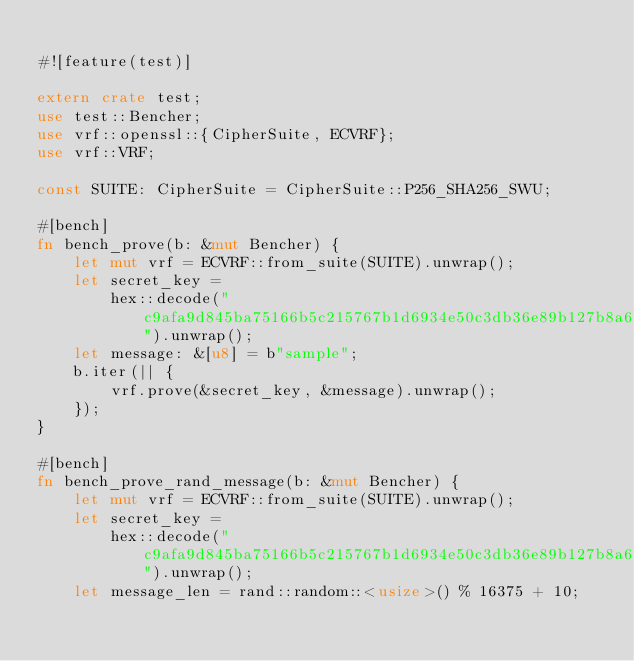Convert code to text. <code><loc_0><loc_0><loc_500><loc_500><_Rust_>
#![feature(test)]

extern crate test;
use test::Bencher;
use vrf::openssl::{CipherSuite, ECVRF};
use vrf::VRF;

const SUITE: CipherSuite = CipherSuite::P256_SHA256_SWU;

#[bench]
fn bench_prove(b: &mut Bencher) {
    let mut vrf = ECVRF::from_suite(SUITE).unwrap();
    let secret_key =
        hex::decode("c9afa9d845ba75166b5c215767b1d6934e50c3db36e89b127b8a622b120f6721").unwrap();
    let message: &[u8] = b"sample";
    b.iter(|| {
        vrf.prove(&secret_key, &message).unwrap();
    });
}

#[bench]
fn bench_prove_rand_message(b: &mut Bencher) {
    let mut vrf = ECVRF::from_suite(SUITE).unwrap();
    let secret_key =
        hex::decode("c9afa9d845ba75166b5c215767b1d6934e50c3db36e89b127b8a622b120f6721").unwrap();
    let message_len = rand::random::<usize>() % 16375 + 10;</code> 